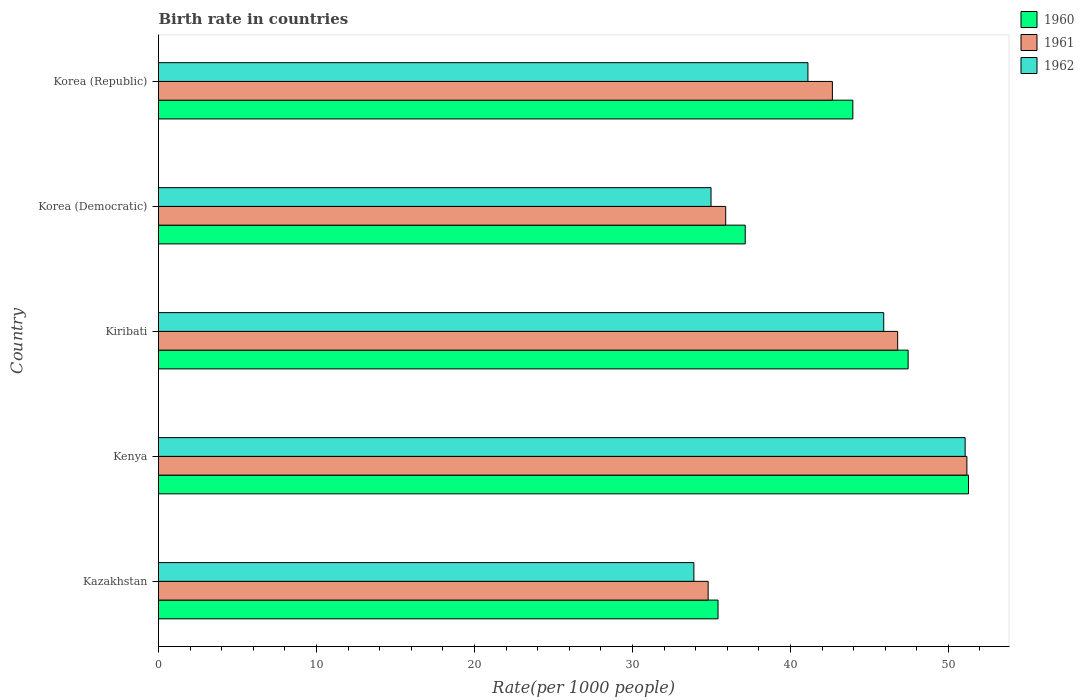How many different coloured bars are there?
Offer a very short reply. 3. How many groups of bars are there?
Keep it short and to the point. 5. What is the label of the 4th group of bars from the top?
Provide a succinct answer. Kenya. In how many cases, is the number of bars for a given country not equal to the number of legend labels?
Keep it short and to the point. 0. What is the birth rate in 1961 in Korea (Democratic)?
Offer a terse response. 35.9. Across all countries, what is the maximum birth rate in 1960?
Provide a short and direct response. 51.27. Across all countries, what is the minimum birth rate in 1961?
Offer a terse response. 34.79. In which country was the birth rate in 1960 maximum?
Provide a succinct answer. Kenya. In which country was the birth rate in 1962 minimum?
Keep it short and to the point. Kazakhstan. What is the total birth rate in 1962 in the graph?
Provide a short and direct response. 206.94. What is the difference between the birth rate in 1961 in Kazakhstan and that in Kenya?
Your answer should be very brief. -16.38. What is the difference between the birth rate in 1960 in Kiribati and the birth rate in 1962 in Kazakhstan?
Offer a very short reply. 13.56. What is the average birth rate in 1962 per country?
Provide a succinct answer. 41.39. What is the difference between the birth rate in 1962 and birth rate in 1961 in Kiribati?
Make the answer very short. -0.88. What is the ratio of the birth rate in 1962 in Kenya to that in Korea (Republic)?
Provide a succinct answer. 1.24. Is the birth rate in 1961 in Kenya less than that in Korea (Democratic)?
Your answer should be compact. No. Is the difference between the birth rate in 1962 in Korea (Democratic) and Korea (Republic) greater than the difference between the birth rate in 1961 in Korea (Democratic) and Korea (Republic)?
Provide a short and direct response. Yes. What is the difference between the highest and the second highest birth rate in 1960?
Provide a succinct answer. 3.82. What is the difference between the highest and the lowest birth rate in 1960?
Your answer should be compact. 15.86. In how many countries, is the birth rate in 1960 greater than the average birth rate in 1960 taken over all countries?
Provide a short and direct response. 3. What does the 2nd bar from the top in Kenya represents?
Provide a short and direct response. 1961. Is it the case that in every country, the sum of the birth rate in 1962 and birth rate in 1961 is greater than the birth rate in 1960?
Your answer should be compact. Yes. How many bars are there?
Make the answer very short. 15. Are all the bars in the graph horizontal?
Ensure brevity in your answer.  Yes. How many countries are there in the graph?
Provide a short and direct response. 5. Does the graph contain grids?
Keep it short and to the point. No. Where does the legend appear in the graph?
Provide a short and direct response. Top right. How are the legend labels stacked?
Provide a short and direct response. Vertical. What is the title of the graph?
Ensure brevity in your answer.  Birth rate in countries. Does "1972" appear as one of the legend labels in the graph?
Offer a very short reply. No. What is the label or title of the X-axis?
Provide a short and direct response. Rate(per 1000 people). What is the label or title of the Y-axis?
Your answer should be very brief. Country. What is the Rate(per 1000 people) of 1960 in Kazakhstan?
Offer a very short reply. 35.42. What is the Rate(per 1000 people) of 1961 in Kazakhstan?
Keep it short and to the point. 34.79. What is the Rate(per 1000 people) in 1962 in Kazakhstan?
Give a very brief answer. 33.89. What is the Rate(per 1000 people) in 1960 in Kenya?
Keep it short and to the point. 51.27. What is the Rate(per 1000 people) in 1961 in Kenya?
Ensure brevity in your answer.  51.17. What is the Rate(per 1000 people) in 1962 in Kenya?
Provide a succinct answer. 51.06. What is the Rate(per 1000 people) of 1960 in Kiribati?
Keep it short and to the point. 47.45. What is the Rate(per 1000 people) of 1961 in Kiribati?
Your response must be concise. 46.79. What is the Rate(per 1000 people) in 1962 in Kiribati?
Keep it short and to the point. 45.91. What is the Rate(per 1000 people) in 1960 in Korea (Democratic)?
Provide a succinct answer. 37.14. What is the Rate(per 1000 people) of 1961 in Korea (Democratic)?
Ensure brevity in your answer.  35.9. What is the Rate(per 1000 people) of 1962 in Korea (Democratic)?
Provide a succinct answer. 34.98. What is the Rate(per 1000 people) of 1960 in Korea (Republic)?
Your answer should be compact. 43.95. What is the Rate(per 1000 people) of 1961 in Korea (Republic)?
Your answer should be very brief. 42.66. What is the Rate(per 1000 people) of 1962 in Korea (Republic)?
Make the answer very short. 41.11. Across all countries, what is the maximum Rate(per 1000 people) in 1960?
Provide a short and direct response. 51.27. Across all countries, what is the maximum Rate(per 1000 people) of 1961?
Ensure brevity in your answer.  51.17. Across all countries, what is the maximum Rate(per 1000 people) in 1962?
Your answer should be very brief. 51.06. Across all countries, what is the minimum Rate(per 1000 people) of 1960?
Ensure brevity in your answer.  35.42. Across all countries, what is the minimum Rate(per 1000 people) in 1961?
Your response must be concise. 34.79. Across all countries, what is the minimum Rate(per 1000 people) in 1962?
Provide a succinct answer. 33.89. What is the total Rate(per 1000 people) of 1960 in the graph?
Provide a short and direct response. 215.23. What is the total Rate(per 1000 people) in 1961 in the graph?
Your response must be concise. 211.32. What is the total Rate(per 1000 people) in 1962 in the graph?
Keep it short and to the point. 206.94. What is the difference between the Rate(per 1000 people) in 1960 in Kazakhstan and that in Kenya?
Provide a short and direct response. -15.86. What is the difference between the Rate(per 1000 people) of 1961 in Kazakhstan and that in Kenya?
Your response must be concise. -16.38. What is the difference between the Rate(per 1000 people) of 1962 in Kazakhstan and that in Kenya?
Your answer should be very brief. -17.17. What is the difference between the Rate(per 1000 people) of 1960 in Kazakhstan and that in Kiribati?
Your response must be concise. -12.03. What is the difference between the Rate(per 1000 people) of 1961 in Kazakhstan and that in Kiribati?
Provide a succinct answer. -12. What is the difference between the Rate(per 1000 people) of 1962 in Kazakhstan and that in Kiribati?
Make the answer very short. -12.02. What is the difference between the Rate(per 1000 people) of 1960 in Kazakhstan and that in Korea (Democratic)?
Ensure brevity in your answer.  -1.72. What is the difference between the Rate(per 1000 people) of 1961 in Kazakhstan and that in Korea (Democratic)?
Provide a succinct answer. -1.11. What is the difference between the Rate(per 1000 people) in 1962 in Kazakhstan and that in Korea (Democratic)?
Provide a succinct answer. -1.08. What is the difference between the Rate(per 1000 people) in 1960 in Kazakhstan and that in Korea (Republic)?
Keep it short and to the point. -8.53. What is the difference between the Rate(per 1000 people) in 1961 in Kazakhstan and that in Korea (Republic)?
Your answer should be compact. -7.86. What is the difference between the Rate(per 1000 people) in 1962 in Kazakhstan and that in Korea (Republic)?
Make the answer very short. -7.22. What is the difference between the Rate(per 1000 people) in 1960 in Kenya and that in Kiribati?
Ensure brevity in your answer.  3.82. What is the difference between the Rate(per 1000 people) in 1961 in Kenya and that in Kiribati?
Give a very brief answer. 4.38. What is the difference between the Rate(per 1000 people) in 1962 in Kenya and that in Kiribati?
Your answer should be very brief. 5.15. What is the difference between the Rate(per 1000 people) in 1960 in Kenya and that in Korea (Democratic)?
Ensure brevity in your answer.  14.13. What is the difference between the Rate(per 1000 people) of 1961 in Kenya and that in Korea (Democratic)?
Your answer should be compact. 15.27. What is the difference between the Rate(per 1000 people) of 1962 in Kenya and that in Korea (Democratic)?
Keep it short and to the point. 16.09. What is the difference between the Rate(per 1000 people) in 1960 in Kenya and that in Korea (Republic)?
Provide a short and direct response. 7.32. What is the difference between the Rate(per 1000 people) in 1961 in Kenya and that in Korea (Republic)?
Ensure brevity in your answer.  8.52. What is the difference between the Rate(per 1000 people) in 1962 in Kenya and that in Korea (Republic)?
Offer a very short reply. 9.95. What is the difference between the Rate(per 1000 people) of 1960 in Kiribati and that in Korea (Democratic)?
Give a very brief answer. 10.31. What is the difference between the Rate(per 1000 people) in 1961 in Kiribati and that in Korea (Democratic)?
Offer a very short reply. 10.89. What is the difference between the Rate(per 1000 people) in 1962 in Kiribati and that in Korea (Democratic)?
Keep it short and to the point. 10.93. What is the difference between the Rate(per 1000 people) of 1960 in Kiribati and that in Korea (Republic)?
Keep it short and to the point. 3.5. What is the difference between the Rate(per 1000 people) in 1961 in Kiribati and that in Korea (Republic)?
Provide a succinct answer. 4.13. What is the difference between the Rate(per 1000 people) of 1962 in Kiribati and that in Korea (Republic)?
Provide a succinct answer. 4.8. What is the difference between the Rate(per 1000 people) in 1960 in Korea (Democratic) and that in Korea (Republic)?
Provide a short and direct response. -6.81. What is the difference between the Rate(per 1000 people) in 1961 in Korea (Democratic) and that in Korea (Republic)?
Give a very brief answer. -6.75. What is the difference between the Rate(per 1000 people) of 1962 in Korea (Democratic) and that in Korea (Republic)?
Your answer should be compact. -6.13. What is the difference between the Rate(per 1000 people) of 1960 in Kazakhstan and the Rate(per 1000 people) of 1961 in Kenya?
Keep it short and to the point. -15.75. What is the difference between the Rate(per 1000 people) of 1960 in Kazakhstan and the Rate(per 1000 people) of 1962 in Kenya?
Provide a short and direct response. -15.64. What is the difference between the Rate(per 1000 people) of 1961 in Kazakhstan and the Rate(per 1000 people) of 1962 in Kenya?
Keep it short and to the point. -16.27. What is the difference between the Rate(per 1000 people) of 1960 in Kazakhstan and the Rate(per 1000 people) of 1961 in Kiribati?
Keep it short and to the point. -11.37. What is the difference between the Rate(per 1000 people) in 1960 in Kazakhstan and the Rate(per 1000 people) in 1962 in Kiribati?
Give a very brief answer. -10.49. What is the difference between the Rate(per 1000 people) of 1961 in Kazakhstan and the Rate(per 1000 people) of 1962 in Kiribati?
Make the answer very short. -11.11. What is the difference between the Rate(per 1000 people) in 1960 in Kazakhstan and the Rate(per 1000 people) in 1961 in Korea (Democratic)?
Keep it short and to the point. -0.49. What is the difference between the Rate(per 1000 people) of 1960 in Kazakhstan and the Rate(per 1000 people) of 1962 in Korea (Democratic)?
Your response must be concise. 0.44. What is the difference between the Rate(per 1000 people) of 1961 in Kazakhstan and the Rate(per 1000 people) of 1962 in Korea (Democratic)?
Your answer should be compact. -0.18. What is the difference between the Rate(per 1000 people) in 1960 in Kazakhstan and the Rate(per 1000 people) in 1961 in Korea (Republic)?
Your answer should be very brief. -7.24. What is the difference between the Rate(per 1000 people) of 1960 in Kazakhstan and the Rate(per 1000 people) of 1962 in Korea (Republic)?
Make the answer very short. -5.69. What is the difference between the Rate(per 1000 people) in 1961 in Kazakhstan and the Rate(per 1000 people) in 1962 in Korea (Republic)?
Your answer should be compact. -6.32. What is the difference between the Rate(per 1000 people) of 1960 in Kenya and the Rate(per 1000 people) of 1961 in Kiribati?
Provide a short and direct response. 4.48. What is the difference between the Rate(per 1000 people) of 1960 in Kenya and the Rate(per 1000 people) of 1962 in Kiribati?
Your answer should be very brief. 5.37. What is the difference between the Rate(per 1000 people) in 1961 in Kenya and the Rate(per 1000 people) in 1962 in Kiribati?
Provide a succinct answer. 5.26. What is the difference between the Rate(per 1000 people) in 1960 in Kenya and the Rate(per 1000 people) in 1961 in Korea (Democratic)?
Offer a very short reply. 15.37. What is the difference between the Rate(per 1000 people) in 1960 in Kenya and the Rate(per 1000 people) in 1962 in Korea (Democratic)?
Provide a succinct answer. 16.3. What is the difference between the Rate(per 1000 people) in 1961 in Kenya and the Rate(per 1000 people) in 1962 in Korea (Democratic)?
Your response must be concise. 16.2. What is the difference between the Rate(per 1000 people) in 1960 in Kenya and the Rate(per 1000 people) in 1961 in Korea (Republic)?
Make the answer very short. 8.62. What is the difference between the Rate(per 1000 people) of 1960 in Kenya and the Rate(per 1000 people) of 1962 in Korea (Republic)?
Your response must be concise. 10.16. What is the difference between the Rate(per 1000 people) in 1961 in Kenya and the Rate(per 1000 people) in 1962 in Korea (Republic)?
Give a very brief answer. 10.06. What is the difference between the Rate(per 1000 people) of 1960 in Kiribati and the Rate(per 1000 people) of 1961 in Korea (Democratic)?
Your answer should be compact. 11.55. What is the difference between the Rate(per 1000 people) in 1960 in Kiribati and the Rate(per 1000 people) in 1962 in Korea (Democratic)?
Provide a succinct answer. 12.48. What is the difference between the Rate(per 1000 people) of 1961 in Kiribati and the Rate(per 1000 people) of 1962 in Korea (Democratic)?
Your response must be concise. 11.81. What is the difference between the Rate(per 1000 people) of 1960 in Kiribati and the Rate(per 1000 people) of 1961 in Korea (Republic)?
Your answer should be very brief. 4.79. What is the difference between the Rate(per 1000 people) in 1960 in Kiribati and the Rate(per 1000 people) in 1962 in Korea (Republic)?
Provide a short and direct response. 6.34. What is the difference between the Rate(per 1000 people) of 1961 in Kiribati and the Rate(per 1000 people) of 1962 in Korea (Republic)?
Give a very brief answer. 5.68. What is the difference between the Rate(per 1000 people) in 1960 in Korea (Democratic) and the Rate(per 1000 people) in 1961 in Korea (Republic)?
Your answer should be compact. -5.52. What is the difference between the Rate(per 1000 people) in 1960 in Korea (Democratic) and the Rate(per 1000 people) in 1962 in Korea (Republic)?
Make the answer very short. -3.97. What is the difference between the Rate(per 1000 people) of 1961 in Korea (Democratic) and the Rate(per 1000 people) of 1962 in Korea (Republic)?
Offer a terse response. -5.21. What is the average Rate(per 1000 people) of 1960 per country?
Your answer should be very brief. 43.05. What is the average Rate(per 1000 people) of 1961 per country?
Provide a short and direct response. 42.26. What is the average Rate(per 1000 people) of 1962 per country?
Offer a terse response. 41.39. What is the difference between the Rate(per 1000 people) in 1960 and Rate(per 1000 people) in 1962 in Kazakhstan?
Make the answer very short. 1.53. What is the difference between the Rate(per 1000 people) of 1961 and Rate(per 1000 people) of 1962 in Kazakhstan?
Keep it short and to the point. 0.9. What is the difference between the Rate(per 1000 people) in 1960 and Rate(per 1000 people) in 1961 in Kenya?
Your answer should be very brief. 0.1. What is the difference between the Rate(per 1000 people) in 1960 and Rate(per 1000 people) in 1962 in Kenya?
Offer a very short reply. 0.21. What is the difference between the Rate(per 1000 people) in 1961 and Rate(per 1000 people) in 1962 in Kenya?
Provide a succinct answer. 0.11. What is the difference between the Rate(per 1000 people) in 1960 and Rate(per 1000 people) in 1961 in Kiribati?
Give a very brief answer. 0.66. What is the difference between the Rate(per 1000 people) in 1960 and Rate(per 1000 people) in 1962 in Kiribati?
Make the answer very short. 1.54. What is the difference between the Rate(per 1000 people) of 1961 and Rate(per 1000 people) of 1962 in Kiribati?
Give a very brief answer. 0.88. What is the difference between the Rate(per 1000 people) in 1960 and Rate(per 1000 people) in 1961 in Korea (Democratic)?
Your answer should be compact. 1.24. What is the difference between the Rate(per 1000 people) in 1960 and Rate(per 1000 people) in 1962 in Korea (Democratic)?
Provide a succinct answer. 2.16. What is the difference between the Rate(per 1000 people) of 1961 and Rate(per 1000 people) of 1962 in Korea (Democratic)?
Provide a succinct answer. 0.93. What is the difference between the Rate(per 1000 people) in 1960 and Rate(per 1000 people) in 1961 in Korea (Republic)?
Offer a terse response. 1.29. What is the difference between the Rate(per 1000 people) in 1960 and Rate(per 1000 people) in 1962 in Korea (Republic)?
Your answer should be very brief. 2.84. What is the difference between the Rate(per 1000 people) of 1961 and Rate(per 1000 people) of 1962 in Korea (Republic)?
Keep it short and to the point. 1.55. What is the ratio of the Rate(per 1000 people) in 1960 in Kazakhstan to that in Kenya?
Your answer should be very brief. 0.69. What is the ratio of the Rate(per 1000 people) of 1961 in Kazakhstan to that in Kenya?
Keep it short and to the point. 0.68. What is the ratio of the Rate(per 1000 people) of 1962 in Kazakhstan to that in Kenya?
Your answer should be very brief. 0.66. What is the ratio of the Rate(per 1000 people) in 1960 in Kazakhstan to that in Kiribati?
Provide a succinct answer. 0.75. What is the ratio of the Rate(per 1000 people) of 1961 in Kazakhstan to that in Kiribati?
Keep it short and to the point. 0.74. What is the ratio of the Rate(per 1000 people) in 1962 in Kazakhstan to that in Kiribati?
Make the answer very short. 0.74. What is the ratio of the Rate(per 1000 people) in 1960 in Kazakhstan to that in Korea (Democratic)?
Provide a short and direct response. 0.95. What is the ratio of the Rate(per 1000 people) in 1961 in Kazakhstan to that in Korea (Democratic)?
Ensure brevity in your answer.  0.97. What is the ratio of the Rate(per 1000 people) in 1962 in Kazakhstan to that in Korea (Democratic)?
Give a very brief answer. 0.97. What is the ratio of the Rate(per 1000 people) in 1960 in Kazakhstan to that in Korea (Republic)?
Provide a succinct answer. 0.81. What is the ratio of the Rate(per 1000 people) of 1961 in Kazakhstan to that in Korea (Republic)?
Provide a succinct answer. 0.82. What is the ratio of the Rate(per 1000 people) in 1962 in Kazakhstan to that in Korea (Republic)?
Your response must be concise. 0.82. What is the ratio of the Rate(per 1000 people) of 1960 in Kenya to that in Kiribati?
Your answer should be very brief. 1.08. What is the ratio of the Rate(per 1000 people) of 1961 in Kenya to that in Kiribati?
Keep it short and to the point. 1.09. What is the ratio of the Rate(per 1000 people) in 1962 in Kenya to that in Kiribati?
Your answer should be very brief. 1.11. What is the ratio of the Rate(per 1000 people) in 1960 in Kenya to that in Korea (Democratic)?
Your answer should be compact. 1.38. What is the ratio of the Rate(per 1000 people) in 1961 in Kenya to that in Korea (Democratic)?
Offer a very short reply. 1.43. What is the ratio of the Rate(per 1000 people) in 1962 in Kenya to that in Korea (Democratic)?
Your response must be concise. 1.46. What is the ratio of the Rate(per 1000 people) in 1960 in Kenya to that in Korea (Republic)?
Give a very brief answer. 1.17. What is the ratio of the Rate(per 1000 people) in 1961 in Kenya to that in Korea (Republic)?
Offer a very short reply. 1.2. What is the ratio of the Rate(per 1000 people) of 1962 in Kenya to that in Korea (Republic)?
Give a very brief answer. 1.24. What is the ratio of the Rate(per 1000 people) in 1960 in Kiribati to that in Korea (Democratic)?
Your response must be concise. 1.28. What is the ratio of the Rate(per 1000 people) of 1961 in Kiribati to that in Korea (Democratic)?
Keep it short and to the point. 1.3. What is the ratio of the Rate(per 1000 people) in 1962 in Kiribati to that in Korea (Democratic)?
Your answer should be compact. 1.31. What is the ratio of the Rate(per 1000 people) in 1960 in Kiribati to that in Korea (Republic)?
Your response must be concise. 1.08. What is the ratio of the Rate(per 1000 people) of 1961 in Kiribati to that in Korea (Republic)?
Your answer should be very brief. 1.1. What is the ratio of the Rate(per 1000 people) of 1962 in Kiribati to that in Korea (Republic)?
Offer a very short reply. 1.12. What is the ratio of the Rate(per 1000 people) of 1960 in Korea (Democratic) to that in Korea (Republic)?
Ensure brevity in your answer.  0.84. What is the ratio of the Rate(per 1000 people) of 1961 in Korea (Democratic) to that in Korea (Republic)?
Give a very brief answer. 0.84. What is the ratio of the Rate(per 1000 people) in 1962 in Korea (Democratic) to that in Korea (Republic)?
Give a very brief answer. 0.85. What is the difference between the highest and the second highest Rate(per 1000 people) in 1960?
Your answer should be compact. 3.82. What is the difference between the highest and the second highest Rate(per 1000 people) in 1961?
Offer a very short reply. 4.38. What is the difference between the highest and the second highest Rate(per 1000 people) of 1962?
Ensure brevity in your answer.  5.15. What is the difference between the highest and the lowest Rate(per 1000 people) in 1960?
Give a very brief answer. 15.86. What is the difference between the highest and the lowest Rate(per 1000 people) in 1961?
Give a very brief answer. 16.38. What is the difference between the highest and the lowest Rate(per 1000 people) of 1962?
Provide a succinct answer. 17.17. 